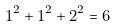<formula> <loc_0><loc_0><loc_500><loc_500>1 ^ { 2 } + 1 ^ { 2 } + 2 ^ { 2 } = 6</formula> 